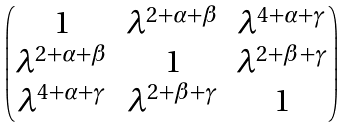<formula> <loc_0><loc_0><loc_500><loc_500>\begin{pmatrix} 1 & \lambda ^ { 2 + \alpha + \beta } & \lambda ^ { 4 + \alpha + \gamma } \\ \lambda ^ { 2 + \alpha + \beta } & 1 & \lambda ^ { 2 + \beta + \gamma } \\ \lambda ^ { 4 + \alpha + \gamma } & \lambda ^ { 2 + \beta + \gamma } & 1 \end{pmatrix}</formula> 